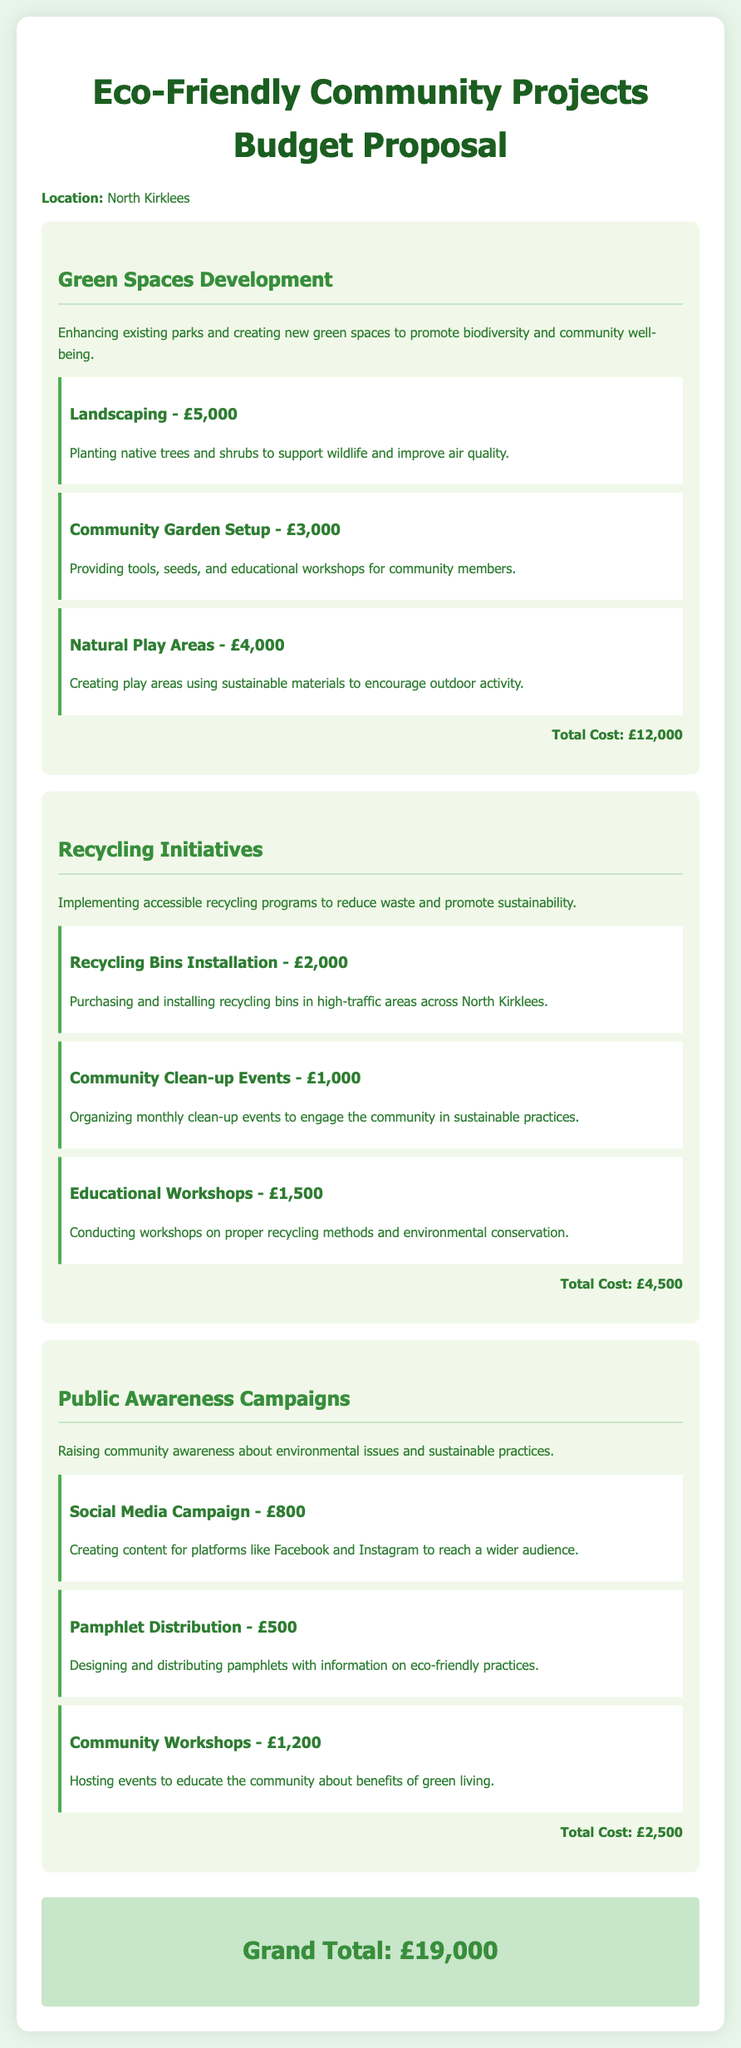what is the total cost for Green Spaces Development? The total cost for Green Spaces Development is stated as £12,000 in the document.
Answer: £12,000 how much is allocated for Community Clean-up Events? The allocation for Community Clean-up Events is specified as £1,000 in the budget proposal.
Answer: £1,000 what is the total budget for Recycling Initiatives? The total budget for Recycling Initiatives is the sum of all related costs, which is £4,500.
Answer: £4,500 how many initiatives are listed under Public Awareness Campaigns? There are three initiatives listed under Public Awareness Campaigns in the document.
Answer: Three what is the grand total for all proposed projects? The grand total for all proposed projects is explicitly mentioned as £19,000 in the document.
Answer: £19,000 which project has a cost of £3,000? The project that has a cost of £3,000 is the Community Garden Setup under Green Spaces Development.
Answer: Community Garden Setup what type of play areas are being proposed? The proposed play areas are described as Natural Play Areas using sustainable materials in the budget proposal.
Answer: Natural Play Areas what is the cost for hosting Community Workshops? The cost for hosting Community Workshops is stated as £1,200 in the budget document.
Answer: £1,200 what is the purpose of the Social Media Campaign? The purpose of the Social Media Campaign is to create content for platforms like Facebook and Instagram to reach a wider audience.
Answer: To reach a wider audience 